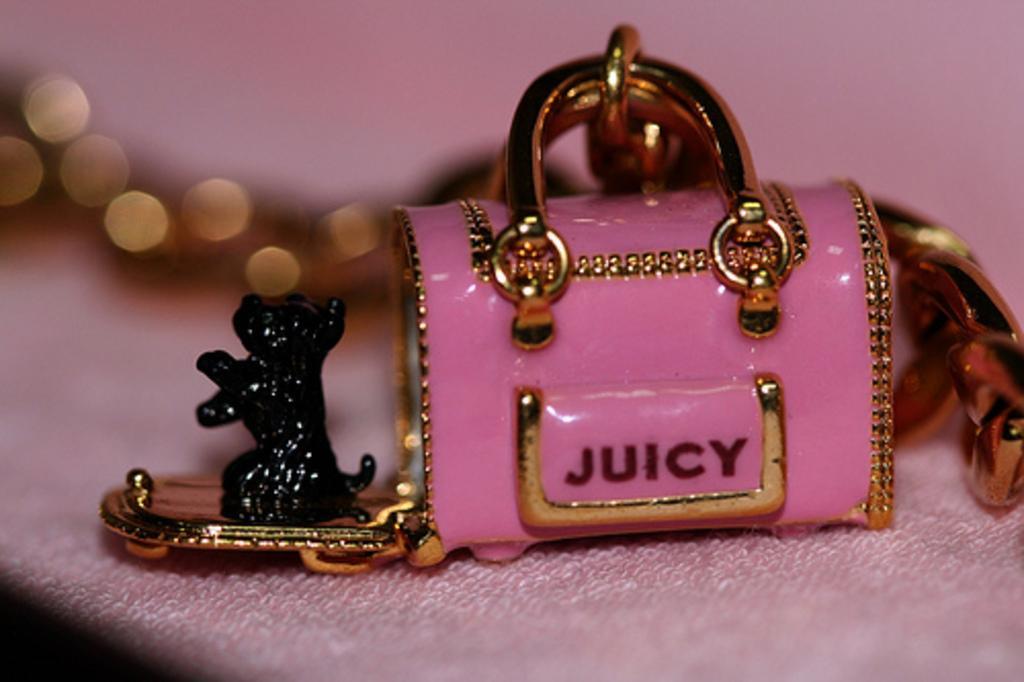Please provide a concise description of this image. In this image there is a toy bag with a text on it and there is a toy dog on the table with a tablecloth on it. 